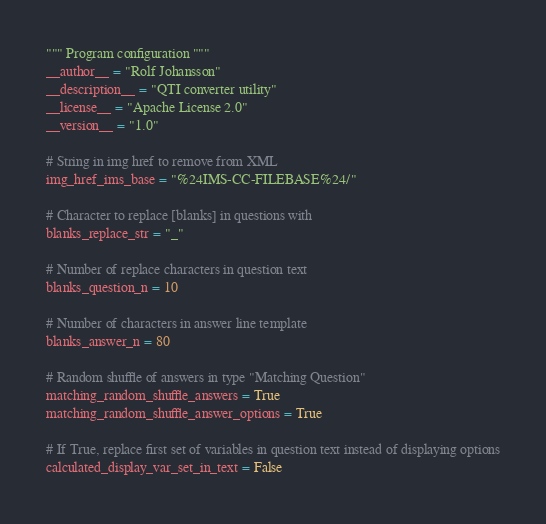<code> <loc_0><loc_0><loc_500><loc_500><_Python_>""" Program configuration """
__author__ = "Rolf Johansson"
__description__ = "QTI converter utility"
__license__ = "Apache License 2.0"
__version__ = "1.0"

# String in img href to remove from XML
img_href_ims_base = "%24IMS-CC-FILEBASE%24/"

# Character to replace [blanks] in questions with
blanks_replace_str = "_"

# Number of replace characters in question text
blanks_question_n = 10

# Number of characters in answer line template
blanks_answer_n = 80

# Random shuffle of answers in type "Matching Question"
matching_random_shuffle_answers = True
matching_random_shuffle_answer_options = True

# If True, replace first set of variables in question text instead of displaying options
calculated_display_var_set_in_text = False
</code> 